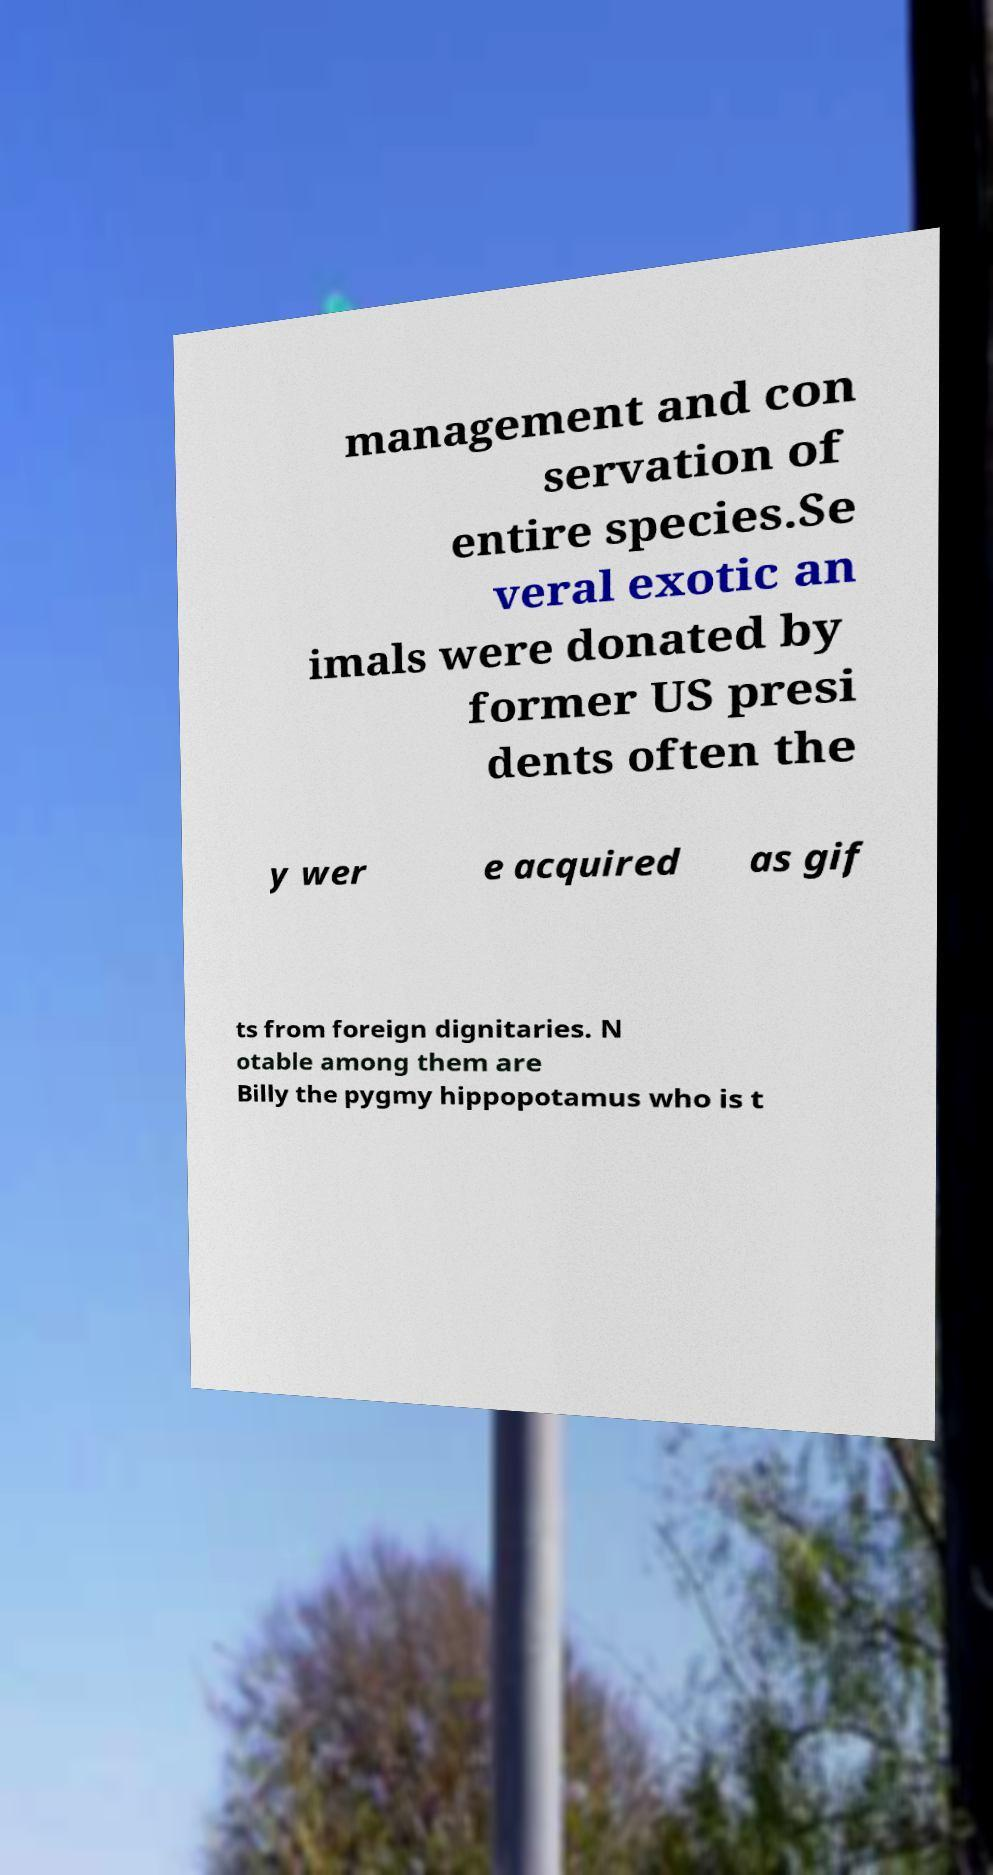I need the written content from this picture converted into text. Can you do that? management and con servation of entire species.Se veral exotic an imals were donated by former US presi dents often the y wer e acquired as gif ts from foreign dignitaries. N otable among them are Billy the pygmy hippopotamus who is t 